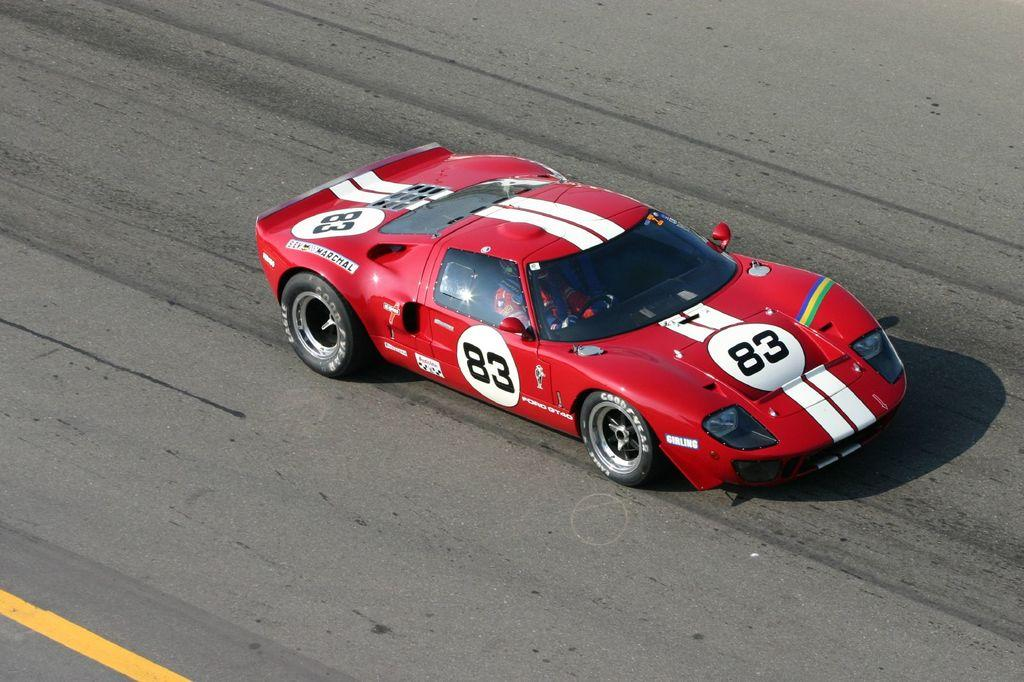What color is the car in the image? The car in the image is red. Where is the car located? The car is on the road. Is there anyone inside the car? Yes, there is a person sitting inside the car. How many roses can be seen in the image? There are no roses present in the image. What fact about the car's engine can be determined from the image? The image does not provide any information about the car's engine, so it cannot be determined from the image. 